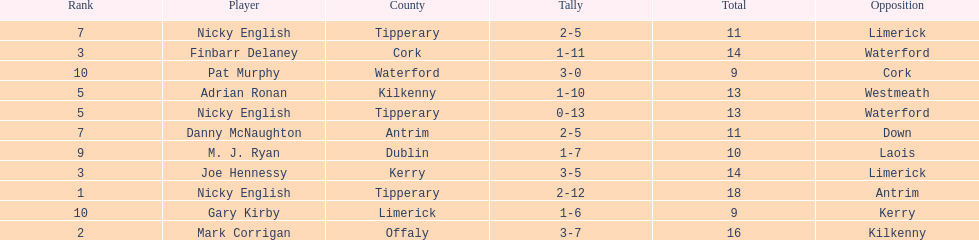What was the average of the totals of nicky english and mark corrigan? 17. 